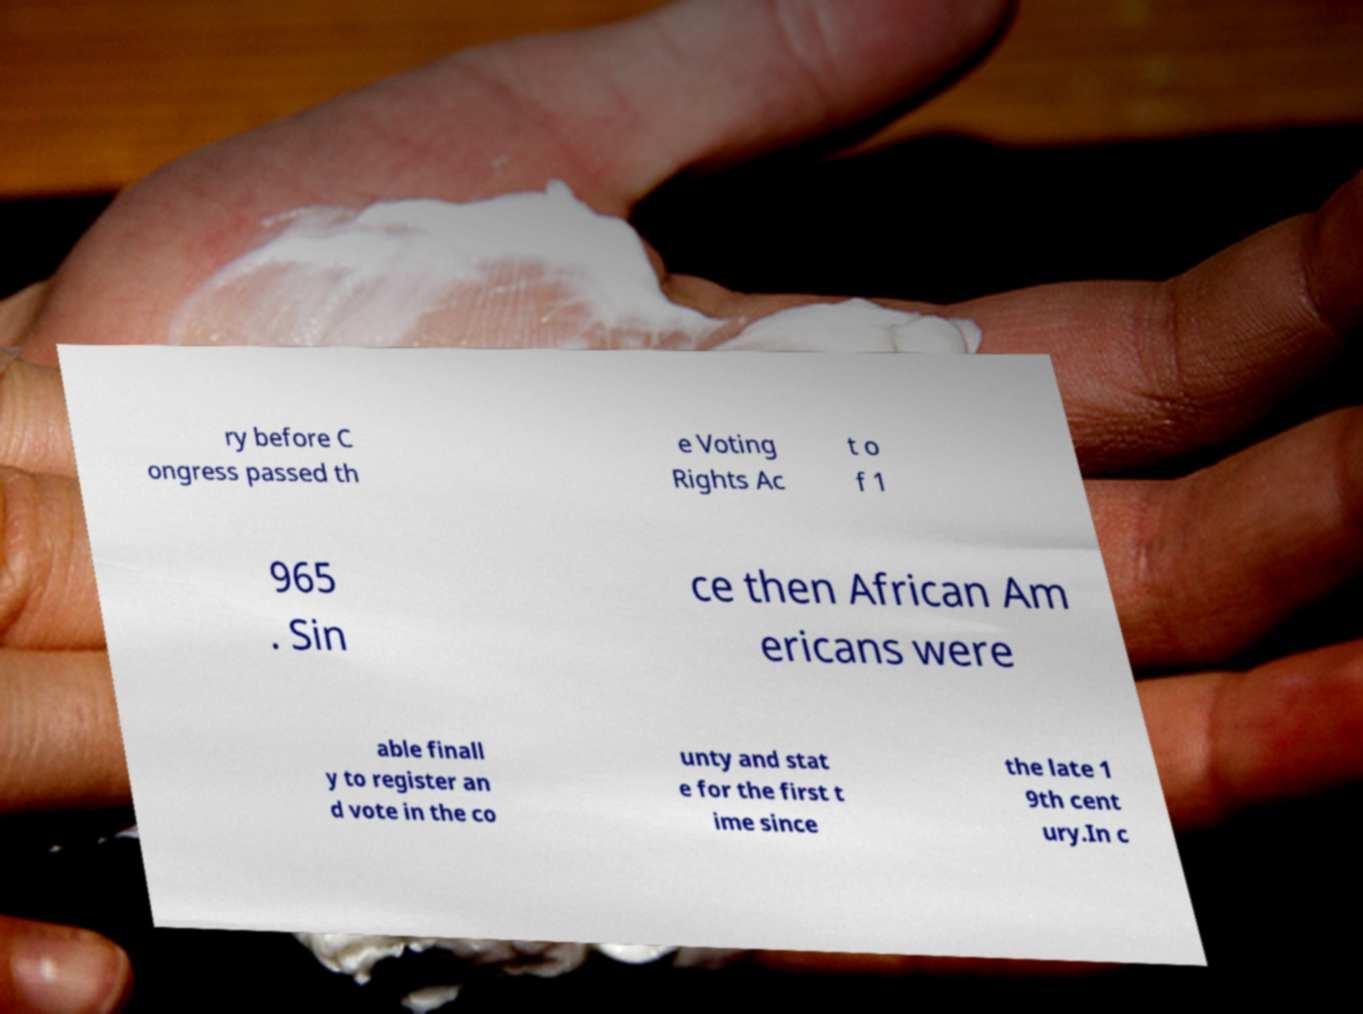For documentation purposes, I need the text within this image transcribed. Could you provide that? ry before C ongress passed th e Voting Rights Ac t o f 1 965 . Sin ce then African Am ericans were able finall y to register an d vote in the co unty and stat e for the first t ime since the late 1 9th cent ury.In c 